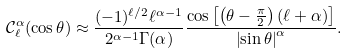Convert formula to latex. <formula><loc_0><loc_0><loc_500><loc_500>\mathcal { C } _ { \ell } ^ { \alpha } ( \cos \theta ) \approx \frac { ( - 1 ) ^ { \ell / 2 } \ell ^ { \alpha - 1 } } { 2 ^ { \alpha - 1 } \Gamma ( \alpha ) } \frac { \cos \left [ \left ( \theta - \frac { \pi } { 2 } \right ) ( \ell + \alpha ) \right ] } { \left | \sin \theta \right | ^ { \alpha } } .</formula> 